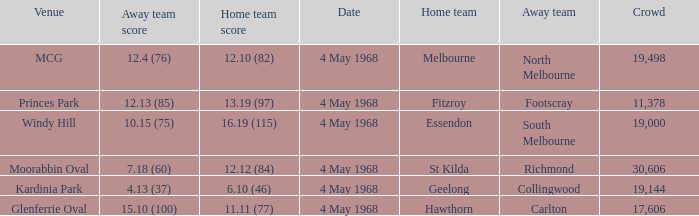Can you give me this table as a dict? {'header': ['Venue', 'Away team score', 'Home team score', 'Date', 'Home team', 'Away team', 'Crowd'], 'rows': [['MCG', '12.4 (76)', '12.10 (82)', '4 May 1968', 'Melbourne', 'North Melbourne', '19,498'], ['Princes Park', '12.13 (85)', '13.19 (97)', '4 May 1968', 'Fitzroy', 'Footscray', '11,378'], ['Windy Hill', '10.15 (75)', '16.19 (115)', '4 May 1968', 'Essendon', 'South Melbourne', '19,000'], ['Moorabbin Oval', '7.18 (60)', '12.12 (84)', '4 May 1968', 'St Kilda', 'Richmond', '30,606'], ['Kardinia Park', '4.13 (37)', '6.10 (46)', '4 May 1968', 'Geelong', 'Collingwood', '19,144'], ['Glenferrie Oval', '15.10 (100)', '11.11 (77)', '4 May 1968', 'Hawthorn', 'Carlton', '17,606']]} What away team played at Kardinia Park? 4.13 (37). 